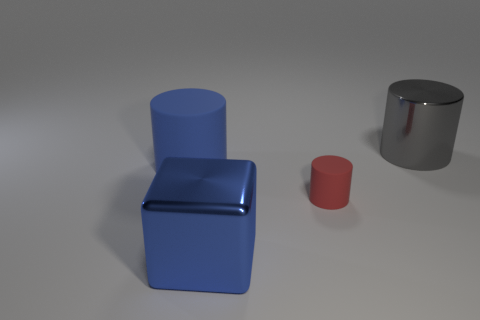Are there more large metal things on the right side of the big shiny cylinder than big gray cylinders?
Give a very brief answer. No. Is there anything else that has the same material as the gray object?
Offer a very short reply. Yes. Is the color of the object that is in front of the tiny red rubber thing the same as the big cylinder to the left of the large gray shiny cylinder?
Make the answer very short. Yes. What material is the big blue object on the left side of the blue thing in front of the big cylinder that is in front of the gray metal thing?
Your answer should be very brief. Rubber. Are there more small objects than big blue things?
Provide a succinct answer. No. Is there any other thing that has the same color as the small cylinder?
Offer a very short reply. No. The other object that is the same material as the tiny red thing is what size?
Make the answer very short. Large. What is the material of the large gray object?
Provide a short and direct response. Metal. What number of red things have the same size as the shiny block?
Your answer should be compact. 0. What shape is the matte object that is the same color as the large metal cube?
Offer a terse response. Cylinder. 